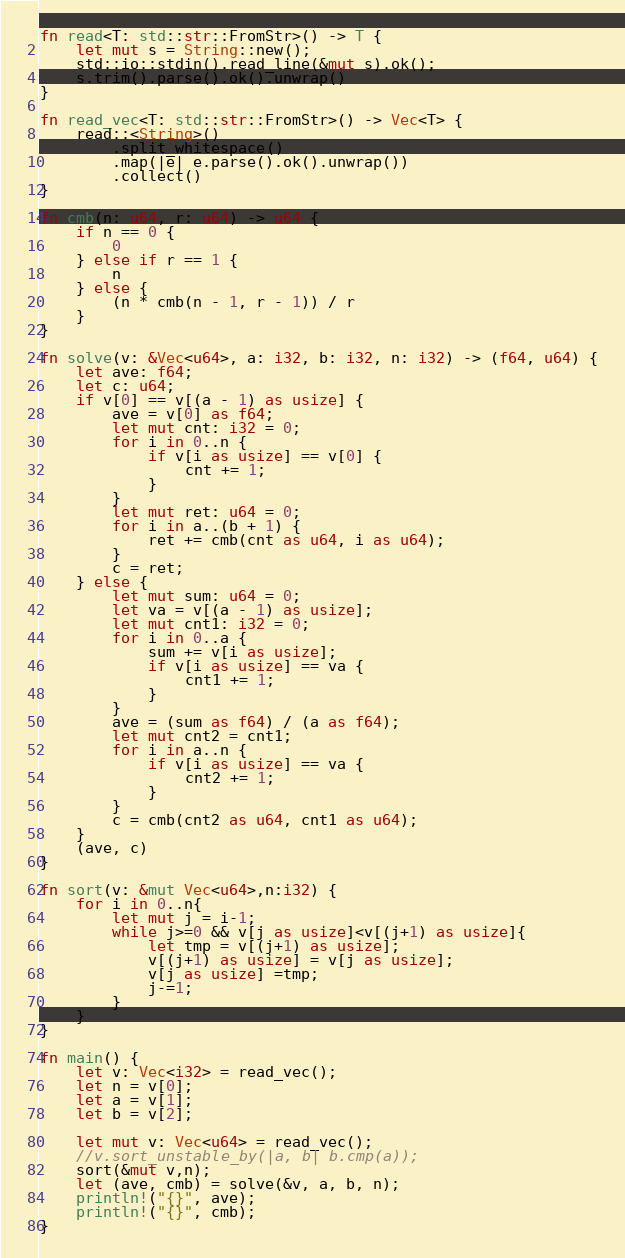<code> <loc_0><loc_0><loc_500><loc_500><_Rust_>fn read<T: std::str::FromStr>() -> T {
    let mut s = String::new();
    std::io::stdin().read_line(&mut s).ok();
    s.trim().parse().ok().unwrap()
}

fn read_vec<T: std::str::FromStr>() -> Vec<T> {
    read::<String>()
        .split_whitespace()
        .map(|e| e.parse().ok().unwrap())
        .collect()
}

fn cmb(n: u64, r: u64) -> u64 {
    if n == 0 {
        0
    } else if r == 1 {
        n
    } else {
        (n * cmb(n - 1, r - 1)) / r
    }
}

fn solve(v: &Vec<u64>, a: i32, b: i32, n: i32) -> (f64, u64) {
    let ave: f64;
    let c: u64;
    if v[0] == v[(a - 1) as usize] {
        ave = v[0] as f64;
        let mut cnt: i32 = 0;
        for i in 0..n {
            if v[i as usize] == v[0] {
                cnt += 1;
            }
        }
        let mut ret: u64 = 0;
        for i in a..(b + 1) {
            ret += cmb(cnt as u64, i as u64);
        }
        c = ret;
    } else {
        let mut sum: u64 = 0;
        let va = v[(a - 1) as usize];
        let mut cnt1: i32 = 0;
        for i in 0..a {
            sum += v[i as usize];
            if v[i as usize] == va {
                cnt1 += 1;
            }
        }
        ave = (sum as f64) / (a as f64);
        let mut cnt2 = cnt1;
        for i in a..n {
            if v[i as usize] == va {
                cnt2 += 1;
            }
        }
        c = cmb(cnt2 as u64, cnt1 as u64);
    }
    (ave, c)
}

fn sort(v: &mut Vec<u64>,n:i32) {
    for i in 0..n{
        let mut j = i-1;
        while j>=0 && v[j as usize]<v[(j+1) as usize]{
            let tmp = v[(j+1) as usize];
            v[(j+1) as usize] = v[j as usize];
            v[j as usize] =tmp;
            j-=1;
        }
    }
}

fn main() {
    let v: Vec<i32> = read_vec();
    let n = v[0];
    let a = v[1];
    let b = v[2];

    let mut v: Vec<u64> = read_vec();
    //v.sort_unstable_by(|a, b| b.cmp(a));
    sort(&mut v,n);
    let (ave, cmb) = solve(&v, a, b, n);
    println!("{}", ave);
    println!("{}", cmb);
}
</code> 